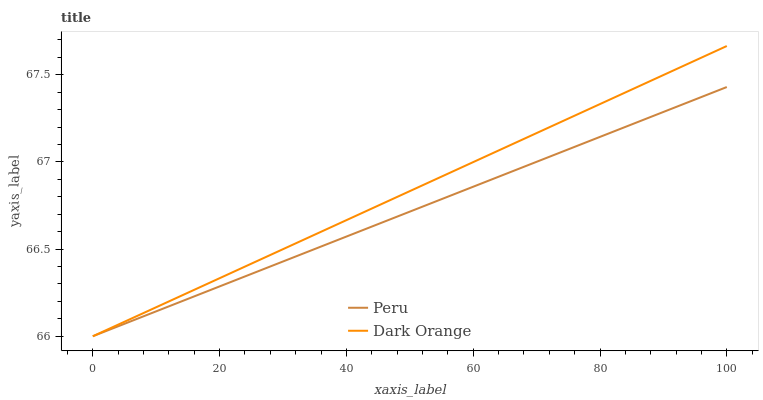Does Peru have the minimum area under the curve?
Answer yes or no. Yes. Does Dark Orange have the maximum area under the curve?
Answer yes or no. Yes. Does Peru have the maximum area under the curve?
Answer yes or no. No. Is Dark Orange the smoothest?
Answer yes or no. Yes. Is Peru the roughest?
Answer yes or no. Yes. Is Peru the smoothest?
Answer yes or no. No. Does Dark Orange have the lowest value?
Answer yes or no. Yes. Does Dark Orange have the highest value?
Answer yes or no. Yes. Does Peru have the highest value?
Answer yes or no. No. Does Peru intersect Dark Orange?
Answer yes or no. Yes. Is Peru less than Dark Orange?
Answer yes or no. No. Is Peru greater than Dark Orange?
Answer yes or no. No. 